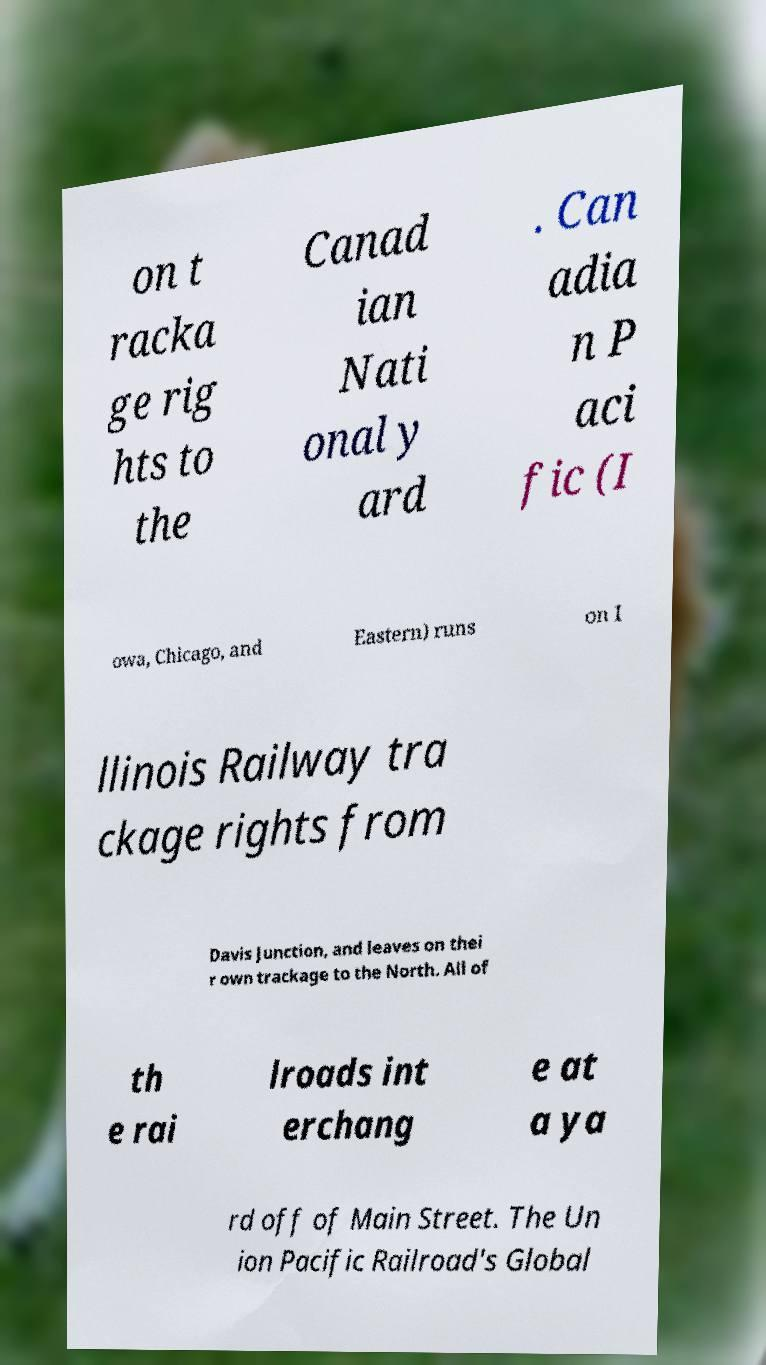Please read and relay the text visible in this image. What does it say? on t racka ge rig hts to the Canad ian Nati onal y ard . Can adia n P aci fic (I owa, Chicago, and Eastern) runs on I llinois Railway tra ckage rights from Davis Junction, and leaves on thei r own trackage to the North. All of th e rai lroads int erchang e at a ya rd off of Main Street. The Un ion Pacific Railroad's Global 